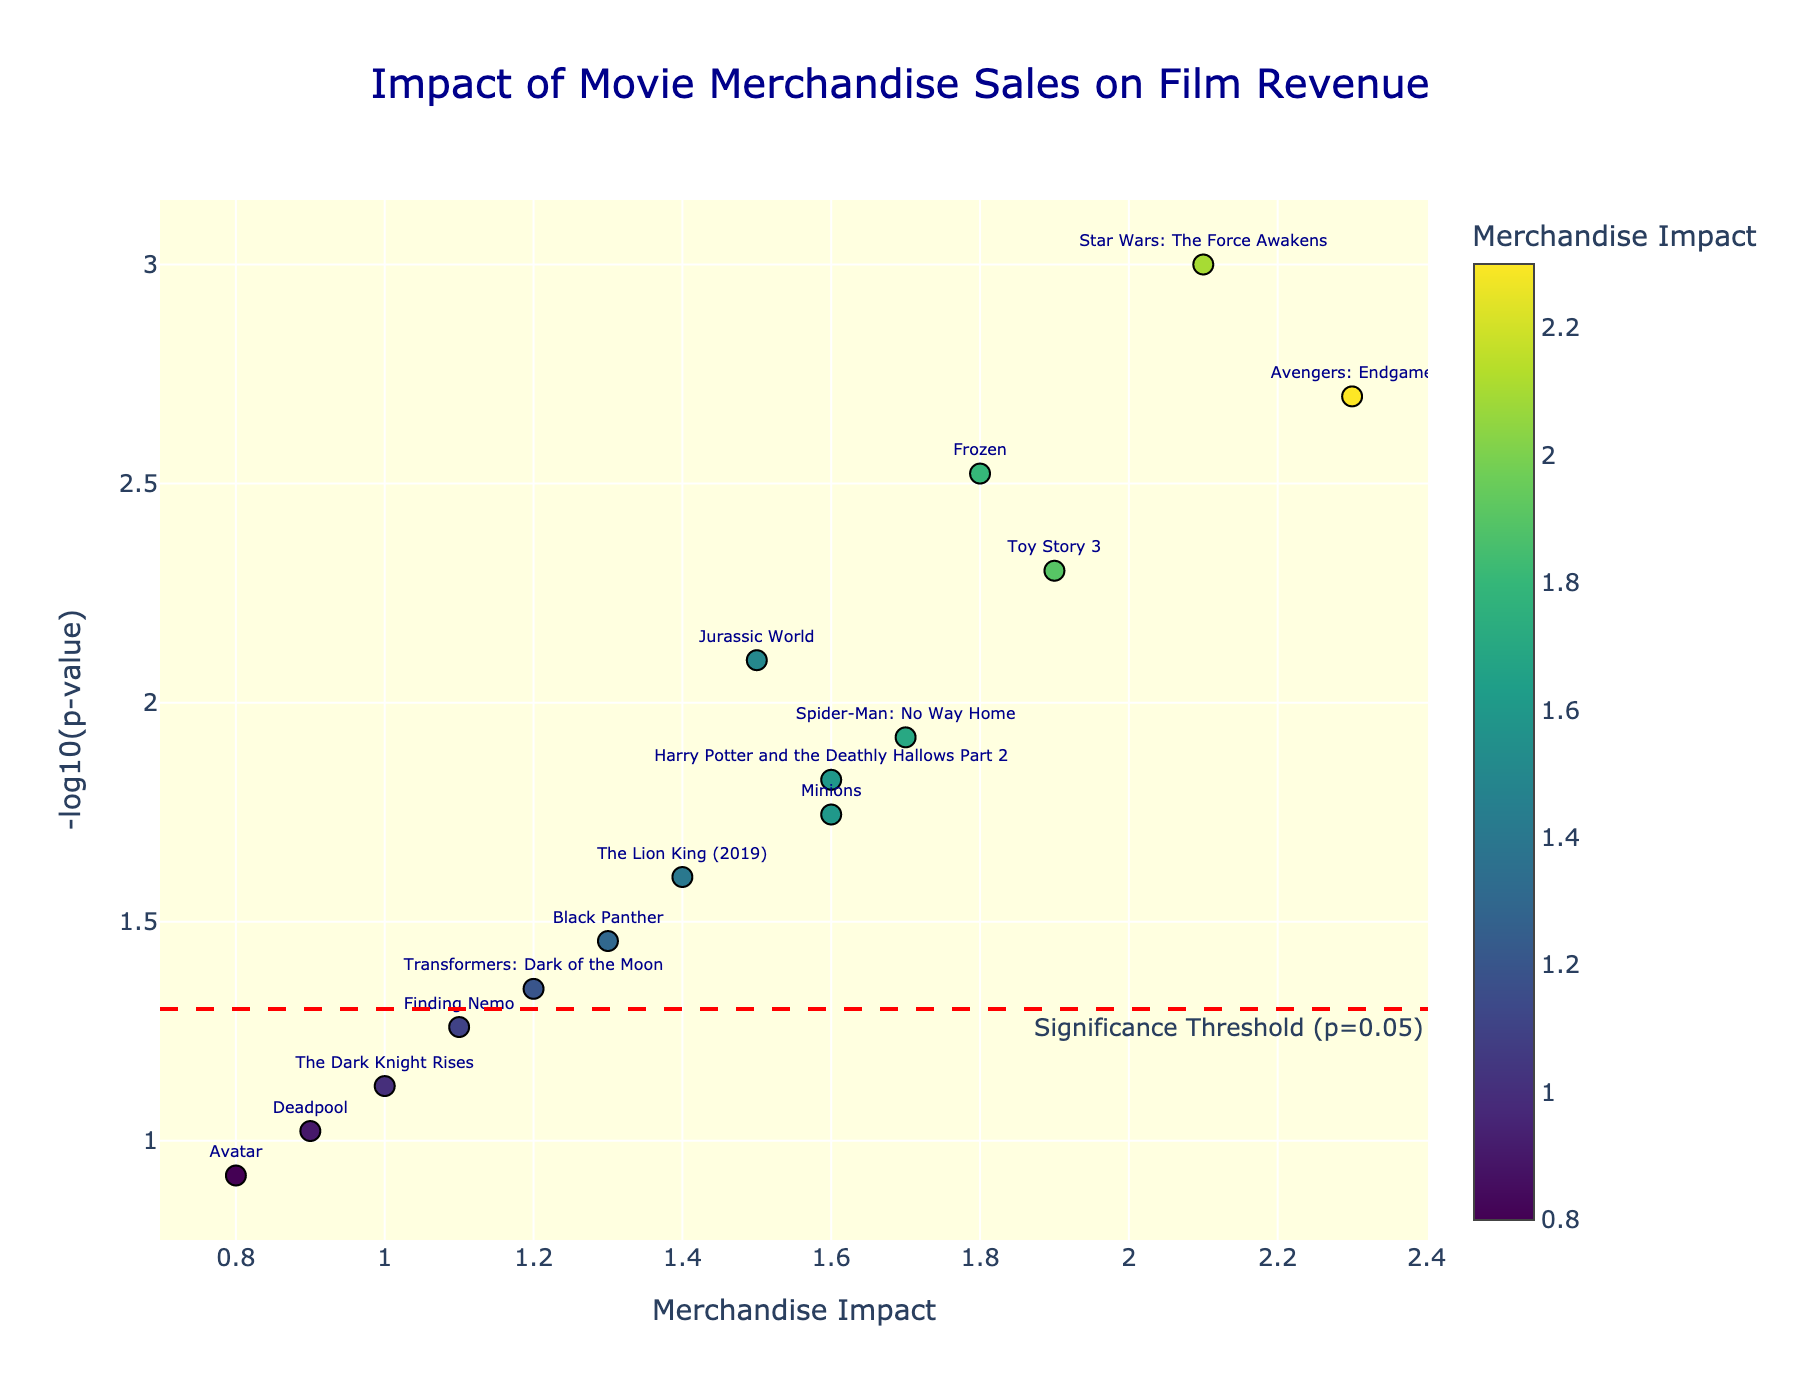What's the title of the figure? The title of the figure is displayed at the top. It reads "Impact of Movie Merchandise Sales on Film Revenue".
Answer: Impact of Movie Merchandise Sales on Film Revenue What is the significance threshold p-value indicated by the red dashed line? The red dashed line annotation specifies the significance threshold. It is at a p-value of 0.05.
Answer: 0.05 Which movie has the highest Merchandise Impact value and what is its significance level? By observing the figure, the movie with the highest Merchandise Impact is "Avengers: Endgame", with a Merchandise Impact value of 2.3. Its significance level or p-value is 0.002.
Answer: Avengers: Endgame How many movies have Merchandise Impact values above 1.5 and are considered significant (p-value < 0.05)? To answer this, count the movies with Merchandise Impact values greater than 1.5 and having a -log10(p-value) above the threshold indicated by the red dashed line (representing 0.05). The movies are: "Star Wars: The Force Awakens", "Frozen", "Jurassic World", "Avengers: Endgame", and "Toy Story 3".
Answer: 5 What is the Merchandise Impact value and -log10(p-value) for "Harry Potter and the Deathly Hallows Part 2"? Identify "Harry Potter and the Deathly Hallows Part 2" on the plot. The Merchandise Impact value is 1.6, and the -log10(p-value) is approximately 1.82 (calculated from its p-value of 0.015).
Answer: 1.6, 1.82 Which movie is just above the significance threshold line with a Merchandise Impact of around 1.6? The movie just above the red dashed line with a Merchandise Impact close to 1.6 is "Minions".
Answer: Minions Compare the Merchandise Impact values of "Spider-Man: No Way Home" and "The Lion King (2019)". Which one has a higher impact? "Spider-Man: No Way Home" and "The Lion King (2019)" are displayed on the plot. "Spider-Man: No Way Home" has an impact of 1.7, while "The Lion King (2019)" has an impact of 1.4. Therefore, "Spider-Man: No Way Home" has a higher impact.
Answer: Spider-Man: No Way Home What can you say about the significance of "Deadpool" in terms of its Merchandise Impact? Locate "Deadpool" on the plot. It has a Merchandise Impact of 0.9 and is below the red dashed line for significance. Its p-value is 0.095, so it is not considered statistically significant.
Answer: Not significant Does "Avatar" have a significant Merchandise Impact on the overall film revenue? The position of "Avatar" on the plot, with a Merchandise Impact of 0.8, is below the significance threshold line. Its p-value is 0.120, indicating it is not significant.
Answer: No Calculate the average Merchandise Impact of all movies considered significant (p-value < 0.05). Identify the significant movies from the plot, and then calculate the average of their Merchandise Impact values: (2.1 + 1.8 + 1.5 + 2.3 + 1.6 + 1.9 + 1.7) / 7 = 13.9 / 7 ≈ 1.99.
Answer: 1.99 